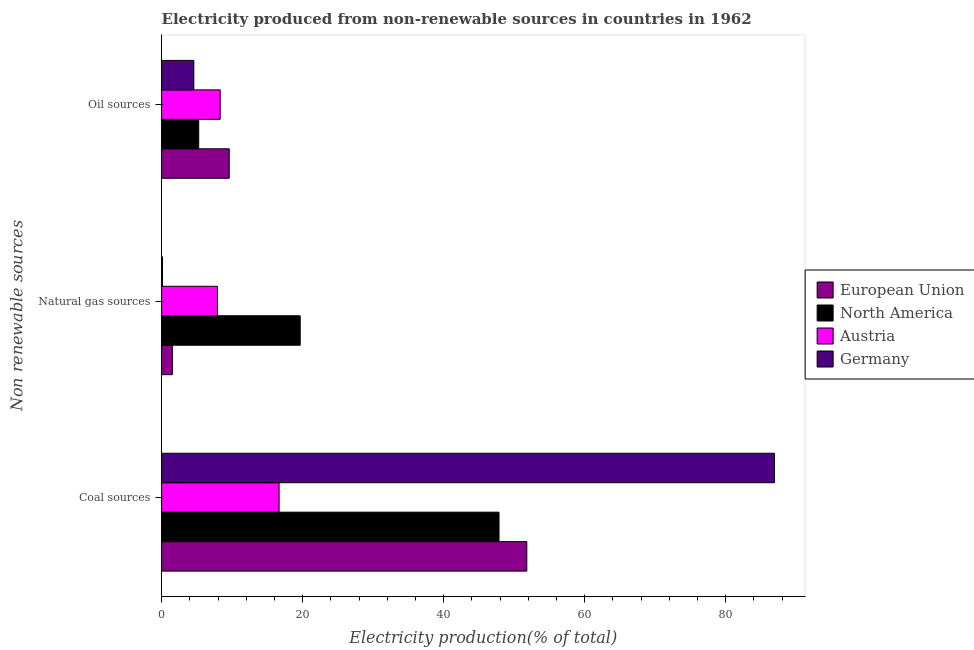How many different coloured bars are there?
Ensure brevity in your answer.  4. How many groups of bars are there?
Your response must be concise. 3. Are the number of bars per tick equal to the number of legend labels?
Your response must be concise. Yes. How many bars are there on the 3rd tick from the top?
Offer a terse response. 4. How many bars are there on the 1st tick from the bottom?
Offer a very short reply. 4. What is the label of the 1st group of bars from the top?
Provide a short and direct response. Oil sources. What is the percentage of electricity produced by oil sources in Austria?
Give a very brief answer. 8.31. Across all countries, what is the maximum percentage of electricity produced by natural gas?
Ensure brevity in your answer.  19.66. Across all countries, what is the minimum percentage of electricity produced by natural gas?
Offer a very short reply. 0.14. What is the total percentage of electricity produced by oil sources in the graph?
Ensure brevity in your answer.  27.75. What is the difference between the percentage of electricity produced by natural gas in Austria and that in European Union?
Your answer should be very brief. 6.39. What is the difference between the percentage of electricity produced by natural gas in North America and the percentage of electricity produced by coal in Germany?
Your answer should be very brief. -67.25. What is the average percentage of electricity produced by oil sources per country?
Your response must be concise. 6.94. What is the difference between the percentage of electricity produced by coal and percentage of electricity produced by oil sources in Austria?
Ensure brevity in your answer.  8.35. In how many countries, is the percentage of electricity produced by natural gas greater than 40 %?
Offer a very short reply. 0. What is the ratio of the percentage of electricity produced by natural gas in Germany to that in North America?
Offer a terse response. 0.01. Is the percentage of electricity produced by oil sources in Austria less than that in Germany?
Provide a short and direct response. No. What is the difference between the highest and the second highest percentage of electricity produced by oil sources?
Keep it short and to the point. 1.28. What is the difference between the highest and the lowest percentage of electricity produced by oil sources?
Your answer should be very brief. 5.02. In how many countries, is the percentage of electricity produced by oil sources greater than the average percentage of electricity produced by oil sources taken over all countries?
Your response must be concise. 2. Is the sum of the percentage of electricity produced by oil sources in Austria and Germany greater than the maximum percentage of electricity produced by natural gas across all countries?
Keep it short and to the point. No. What does the 4th bar from the top in Natural gas sources represents?
Give a very brief answer. European Union. What does the 3rd bar from the bottom in Oil sources represents?
Keep it short and to the point. Austria. How many bars are there?
Your answer should be compact. 12. Are all the bars in the graph horizontal?
Ensure brevity in your answer.  Yes. What is the difference between two consecutive major ticks on the X-axis?
Offer a terse response. 20. Are the values on the major ticks of X-axis written in scientific E-notation?
Give a very brief answer. No. Does the graph contain any zero values?
Your answer should be compact. No. Does the graph contain grids?
Your answer should be compact. No. Where does the legend appear in the graph?
Your answer should be compact. Center right. How are the legend labels stacked?
Provide a succinct answer. Vertical. What is the title of the graph?
Offer a terse response. Electricity produced from non-renewable sources in countries in 1962. What is the label or title of the X-axis?
Your answer should be very brief. Electricity production(% of total). What is the label or title of the Y-axis?
Ensure brevity in your answer.  Non renewable sources. What is the Electricity production(% of total) of European Union in Coal sources?
Make the answer very short. 51.79. What is the Electricity production(% of total) in North America in Coal sources?
Your response must be concise. 47.85. What is the Electricity production(% of total) of Austria in Coal sources?
Make the answer very short. 16.66. What is the Electricity production(% of total) in Germany in Coal sources?
Your answer should be compact. 86.91. What is the Electricity production(% of total) in European Union in Natural gas sources?
Make the answer very short. 1.53. What is the Electricity production(% of total) in North America in Natural gas sources?
Give a very brief answer. 19.66. What is the Electricity production(% of total) in Austria in Natural gas sources?
Offer a very short reply. 7.92. What is the Electricity production(% of total) of Germany in Natural gas sources?
Make the answer very short. 0.14. What is the Electricity production(% of total) in European Union in Oil sources?
Your response must be concise. 9.6. What is the Electricity production(% of total) in North America in Oil sources?
Provide a short and direct response. 5.27. What is the Electricity production(% of total) of Austria in Oil sources?
Offer a terse response. 8.31. What is the Electricity production(% of total) of Germany in Oil sources?
Make the answer very short. 4.57. Across all Non renewable sources, what is the maximum Electricity production(% of total) of European Union?
Make the answer very short. 51.79. Across all Non renewable sources, what is the maximum Electricity production(% of total) in North America?
Your answer should be very brief. 47.85. Across all Non renewable sources, what is the maximum Electricity production(% of total) of Austria?
Offer a terse response. 16.66. Across all Non renewable sources, what is the maximum Electricity production(% of total) in Germany?
Keep it short and to the point. 86.91. Across all Non renewable sources, what is the minimum Electricity production(% of total) of European Union?
Your answer should be very brief. 1.53. Across all Non renewable sources, what is the minimum Electricity production(% of total) of North America?
Your answer should be compact. 5.27. Across all Non renewable sources, what is the minimum Electricity production(% of total) in Austria?
Your answer should be very brief. 7.92. Across all Non renewable sources, what is the minimum Electricity production(% of total) of Germany?
Your answer should be compact. 0.14. What is the total Electricity production(% of total) in European Union in the graph?
Your answer should be very brief. 62.92. What is the total Electricity production(% of total) of North America in the graph?
Give a very brief answer. 72.78. What is the total Electricity production(% of total) in Austria in the graph?
Ensure brevity in your answer.  32.9. What is the total Electricity production(% of total) of Germany in the graph?
Ensure brevity in your answer.  91.62. What is the difference between the Electricity production(% of total) of European Union in Coal sources and that in Natural gas sources?
Provide a succinct answer. 50.26. What is the difference between the Electricity production(% of total) of North America in Coal sources and that in Natural gas sources?
Offer a terse response. 28.19. What is the difference between the Electricity production(% of total) of Austria in Coal sources and that in Natural gas sources?
Give a very brief answer. 8.74. What is the difference between the Electricity production(% of total) of Germany in Coal sources and that in Natural gas sources?
Keep it short and to the point. 86.77. What is the difference between the Electricity production(% of total) of European Union in Coal sources and that in Oil sources?
Make the answer very short. 42.19. What is the difference between the Electricity production(% of total) of North America in Coal sources and that in Oil sources?
Keep it short and to the point. 42.58. What is the difference between the Electricity production(% of total) in Austria in Coal sources and that in Oil sources?
Your answer should be very brief. 8.35. What is the difference between the Electricity production(% of total) of Germany in Coal sources and that in Oil sources?
Offer a very short reply. 82.34. What is the difference between the Electricity production(% of total) of European Union in Natural gas sources and that in Oil sources?
Your answer should be compact. -8.07. What is the difference between the Electricity production(% of total) of North America in Natural gas sources and that in Oil sources?
Your answer should be compact. 14.39. What is the difference between the Electricity production(% of total) of Austria in Natural gas sources and that in Oil sources?
Give a very brief answer. -0.39. What is the difference between the Electricity production(% of total) in Germany in Natural gas sources and that in Oil sources?
Your answer should be very brief. -4.44. What is the difference between the Electricity production(% of total) in European Union in Coal sources and the Electricity production(% of total) in North America in Natural gas sources?
Ensure brevity in your answer.  32.13. What is the difference between the Electricity production(% of total) of European Union in Coal sources and the Electricity production(% of total) of Austria in Natural gas sources?
Ensure brevity in your answer.  43.87. What is the difference between the Electricity production(% of total) in European Union in Coal sources and the Electricity production(% of total) in Germany in Natural gas sources?
Your answer should be very brief. 51.65. What is the difference between the Electricity production(% of total) in North America in Coal sources and the Electricity production(% of total) in Austria in Natural gas sources?
Your answer should be very brief. 39.92. What is the difference between the Electricity production(% of total) in North America in Coal sources and the Electricity production(% of total) in Germany in Natural gas sources?
Keep it short and to the point. 47.71. What is the difference between the Electricity production(% of total) of Austria in Coal sources and the Electricity production(% of total) of Germany in Natural gas sources?
Keep it short and to the point. 16.53. What is the difference between the Electricity production(% of total) of European Union in Coal sources and the Electricity production(% of total) of North America in Oil sources?
Offer a very short reply. 46.52. What is the difference between the Electricity production(% of total) of European Union in Coal sources and the Electricity production(% of total) of Austria in Oil sources?
Provide a short and direct response. 43.48. What is the difference between the Electricity production(% of total) of European Union in Coal sources and the Electricity production(% of total) of Germany in Oil sources?
Provide a succinct answer. 47.22. What is the difference between the Electricity production(% of total) in North America in Coal sources and the Electricity production(% of total) in Austria in Oil sources?
Offer a terse response. 39.54. What is the difference between the Electricity production(% of total) of North America in Coal sources and the Electricity production(% of total) of Germany in Oil sources?
Offer a very short reply. 43.28. What is the difference between the Electricity production(% of total) in Austria in Coal sources and the Electricity production(% of total) in Germany in Oil sources?
Give a very brief answer. 12.09. What is the difference between the Electricity production(% of total) of European Union in Natural gas sources and the Electricity production(% of total) of North America in Oil sources?
Make the answer very short. -3.74. What is the difference between the Electricity production(% of total) of European Union in Natural gas sources and the Electricity production(% of total) of Austria in Oil sources?
Ensure brevity in your answer.  -6.78. What is the difference between the Electricity production(% of total) of European Union in Natural gas sources and the Electricity production(% of total) of Germany in Oil sources?
Offer a very short reply. -3.04. What is the difference between the Electricity production(% of total) of North America in Natural gas sources and the Electricity production(% of total) of Austria in Oil sources?
Give a very brief answer. 11.35. What is the difference between the Electricity production(% of total) of North America in Natural gas sources and the Electricity production(% of total) of Germany in Oil sources?
Ensure brevity in your answer.  15.09. What is the difference between the Electricity production(% of total) of Austria in Natural gas sources and the Electricity production(% of total) of Germany in Oil sources?
Your answer should be very brief. 3.35. What is the average Electricity production(% of total) in European Union per Non renewable sources?
Offer a terse response. 20.97. What is the average Electricity production(% of total) of North America per Non renewable sources?
Give a very brief answer. 24.26. What is the average Electricity production(% of total) of Austria per Non renewable sources?
Provide a succinct answer. 10.97. What is the average Electricity production(% of total) in Germany per Non renewable sources?
Offer a terse response. 30.54. What is the difference between the Electricity production(% of total) in European Union and Electricity production(% of total) in North America in Coal sources?
Provide a succinct answer. 3.94. What is the difference between the Electricity production(% of total) in European Union and Electricity production(% of total) in Austria in Coal sources?
Offer a very short reply. 35.12. What is the difference between the Electricity production(% of total) of European Union and Electricity production(% of total) of Germany in Coal sources?
Your response must be concise. -35.12. What is the difference between the Electricity production(% of total) in North America and Electricity production(% of total) in Austria in Coal sources?
Offer a terse response. 31.18. What is the difference between the Electricity production(% of total) of North America and Electricity production(% of total) of Germany in Coal sources?
Your response must be concise. -39.06. What is the difference between the Electricity production(% of total) of Austria and Electricity production(% of total) of Germany in Coal sources?
Your answer should be very brief. -70.24. What is the difference between the Electricity production(% of total) in European Union and Electricity production(% of total) in North America in Natural gas sources?
Provide a succinct answer. -18.13. What is the difference between the Electricity production(% of total) in European Union and Electricity production(% of total) in Austria in Natural gas sources?
Provide a succinct answer. -6.39. What is the difference between the Electricity production(% of total) in European Union and Electricity production(% of total) in Germany in Natural gas sources?
Ensure brevity in your answer.  1.39. What is the difference between the Electricity production(% of total) in North America and Electricity production(% of total) in Austria in Natural gas sources?
Your answer should be very brief. 11.74. What is the difference between the Electricity production(% of total) in North America and Electricity production(% of total) in Germany in Natural gas sources?
Ensure brevity in your answer.  19.52. What is the difference between the Electricity production(% of total) of Austria and Electricity production(% of total) of Germany in Natural gas sources?
Your response must be concise. 7.79. What is the difference between the Electricity production(% of total) in European Union and Electricity production(% of total) in North America in Oil sources?
Your answer should be very brief. 4.33. What is the difference between the Electricity production(% of total) in European Union and Electricity production(% of total) in Austria in Oil sources?
Offer a terse response. 1.28. What is the difference between the Electricity production(% of total) of European Union and Electricity production(% of total) of Germany in Oil sources?
Your answer should be compact. 5.02. What is the difference between the Electricity production(% of total) in North America and Electricity production(% of total) in Austria in Oil sources?
Your answer should be very brief. -3.05. What is the difference between the Electricity production(% of total) in North America and Electricity production(% of total) in Germany in Oil sources?
Your answer should be compact. 0.69. What is the difference between the Electricity production(% of total) of Austria and Electricity production(% of total) of Germany in Oil sources?
Your answer should be very brief. 3.74. What is the ratio of the Electricity production(% of total) of European Union in Coal sources to that in Natural gas sources?
Your answer should be very brief. 33.83. What is the ratio of the Electricity production(% of total) in North America in Coal sources to that in Natural gas sources?
Your response must be concise. 2.43. What is the ratio of the Electricity production(% of total) in Austria in Coal sources to that in Natural gas sources?
Your response must be concise. 2.1. What is the ratio of the Electricity production(% of total) of Germany in Coal sources to that in Natural gas sources?
Offer a very short reply. 637.97. What is the ratio of the Electricity production(% of total) in European Union in Coal sources to that in Oil sources?
Your answer should be compact. 5.4. What is the ratio of the Electricity production(% of total) in North America in Coal sources to that in Oil sources?
Offer a very short reply. 9.08. What is the ratio of the Electricity production(% of total) in Austria in Coal sources to that in Oil sources?
Provide a short and direct response. 2. What is the ratio of the Electricity production(% of total) of Germany in Coal sources to that in Oil sources?
Offer a very short reply. 19.01. What is the ratio of the Electricity production(% of total) of European Union in Natural gas sources to that in Oil sources?
Keep it short and to the point. 0.16. What is the ratio of the Electricity production(% of total) of North America in Natural gas sources to that in Oil sources?
Keep it short and to the point. 3.73. What is the ratio of the Electricity production(% of total) of Austria in Natural gas sources to that in Oil sources?
Your response must be concise. 0.95. What is the ratio of the Electricity production(% of total) in Germany in Natural gas sources to that in Oil sources?
Keep it short and to the point. 0.03. What is the difference between the highest and the second highest Electricity production(% of total) in European Union?
Your answer should be compact. 42.19. What is the difference between the highest and the second highest Electricity production(% of total) in North America?
Your answer should be compact. 28.19. What is the difference between the highest and the second highest Electricity production(% of total) of Austria?
Provide a succinct answer. 8.35. What is the difference between the highest and the second highest Electricity production(% of total) in Germany?
Your response must be concise. 82.34. What is the difference between the highest and the lowest Electricity production(% of total) of European Union?
Give a very brief answer. 50.26. What is the difference between the highest and the lowest Electricity production(% of total) in North America?
Make the answer very short. 42.58. What is the difference between the highest and the lowest Electricity production(% of total) in Austria?
Offer a very short reply. 8.74. What is the difference between the highest and the lowest Electricity production(% of total) of Germany?
Ensure brevity in your answer.  86.77. 